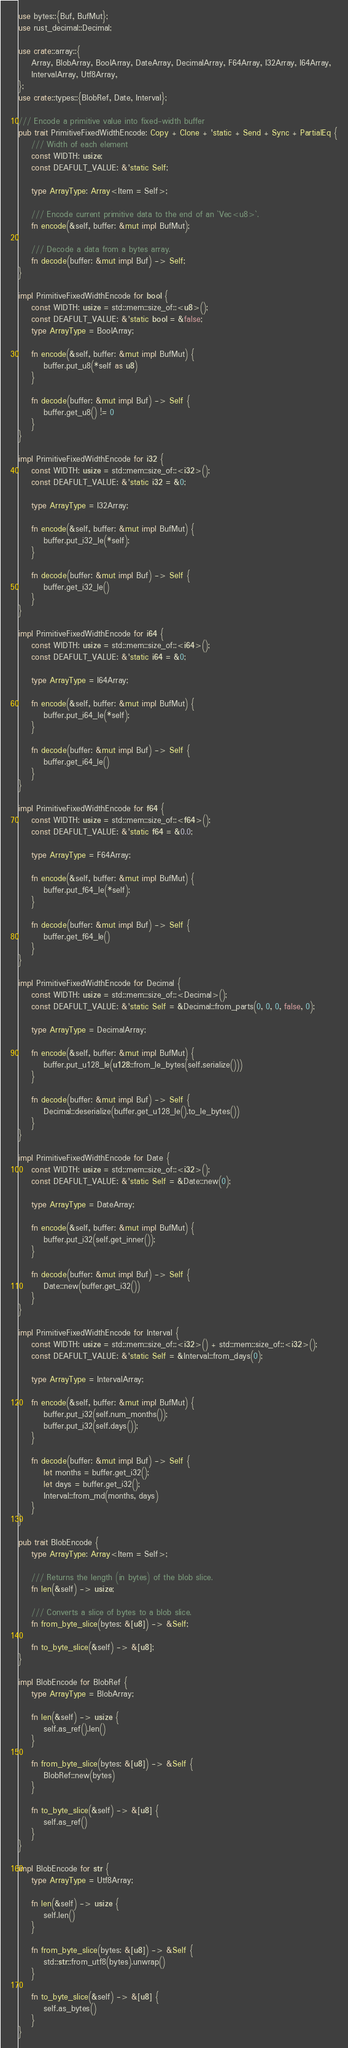<code> <loc_0><loc_0><loc_500><loc_500><_Rust_>
use bytes::{Buf, BufMut};
use rust_decimal::Decimal;

use crate::array::{
    Array, BlobArray, BoolArray, DateArray, DecimalArray, F64Array, I32Array, I64Array,
    IntervalArray, Utf8Array,
};
use crate::types::{BlobRef, Date, Interval};

/// Encode a primitive value into fixed-width buffer
pub trait PrimitiveFixedWidthEncode: Copy + Clone + 'static + Send + Sync + PartialEq {
    /// Width of each element
    const WIDTH: usize;
    const DEAFULT_VALUE: &'static Self;

    type ArrayType: Array<Item = Self>;

    /// Encode current primitive data to the end of an `Vec<u8>`.
    fn encode(&self, buffer: &mut impl BufMut);

    /// Decode a data from a bytes array.
    fn decode(buffer: &mut impl Buf) -> Self;
}

impl PrimitiveFixedWidthEncode for bool {
    const WIDTH: usize = std::mem::size_of::<u8>();
    const DEAFULT_VALUE: &'static bool = &false;
    type ArrayType = BoolArray;

    fn encode(&self, buffer: &mut impl BufMut) {
        buffer.put_u8(*self as u8)
    }

    fn decode(buffer: &mut impl Buf) -> Self {
        buffer.get_u8() != 0
    }
}

impl PrimitiveFixedWidthEncode for i32 {
    const WIDTH: usize = std::mem::size_of::<i32>();
    const DEAFULT_VALUE: &'static i32 = &0;

    type ArrayType = I32Array;

    fn encode(&self, buffer: &mut impl BufMut) {
        buffer.put_i32_le(*self);
    }

    fn decode(buffer: &mut impl Buf) -> Self {
        buffer.get_i32_le()
    }
}

impl PrimitiveFixedWidthEncode for i64 {
    const WIDTH: usize = std::mem::size_of::<i64>();
    const DEAFULT_VALUE: &'static i64 = &0;

    type ArrayType = I64Array;

    fn encode(&self, buffer: &mut impl BufMut) {
        buffer.put_i64_le(*self);
    }

    fn decode(buffer: &mut impl Buf) -> Self {
        buffer.get_i64_le()
    }
}

impl PrimitiveFixedWidthEncode for f64 {
    const WIDTH: usize = std::mem::size_of::<f64>();
    const DEAFULT_VALUE: &'static f64 = &0.0;

    type ArrayType = F64Array;

    fn encode(&self, buffer: &mut impl BufMut) {
        buffer.put_f64_le(*self);
    }

    fn decode(buffer: &mut impl Buf) -> Self {
        buffer.get_f64_le()
    }
}

impl PrimitiveFixedWidthEncode for Decimal {
    const WIDTH: usize = std::mem::size_of::<Decimal>();
    const DEAFULT_VALUE: &'static Self = &Decimal::from_parts(0, 0, 0, false, 0);

    type ArrayType = DecimalArray;

    fn encode(&self, buffer: &mut impl BufMut) {
        buffer.put_u128_le(u128::from_le_bytes(self.serialize()))
    }

    fn decode(buffer: &mut impl Buf) -> Self {
        Decimal::deserialize(buffer.get_u128_le().to_le_bytes())
    }
}

impl PrimitiveFixedWidthEncode for Date {
    const WIDTH: usize = std::mem::size_of::<i32>();
    const DEAFULT_VALUE: &'static Self = &Date::new(0);

    type ArrayType = DateArray;

    fn encode(&self, buffer: &mut impl BufMut) {
        buffer.put_i32(self.get_inner());
    }

    fn decode(buffer: &mut impl Buf) -> Self {
        Date::new(buffer.get_i32())
    }
}

impl PrimitiveFixedWidthEncode for Interval {
    const WIDTH: usize = std::mem::size_of::<i32>() + std::mem::size_of::<i32>();
    const DEAFULT_VALUE: &'static Self = &Interval::from_days(0);

    type ArrayType = IntervalArray;

    fn encode(&self, buffer: &mut impl BufMut) {
        buffer.put_i32(self.num_months());
        buffer.put_i32(self.days());
    }

    fn decode(buffer: &mut impl Buf) -> Self {
        let months = buffer.get_i32();
        let days = buffer.get_i32();
        Interval::from_md(months, days)
    }
}

pub trait BlobEncode {
    type ArrayType: Array<Item = Self>;

    /// Returns the length (in bytes) of the blob slice.
    fn len(&self) -> usize;

    /// Converts a slice of bytes to a blob slice.
    fn from_byte_slice(bytes: &[u8]) -> &Self;

    fn to_byte_slice(&self) -> &[u8];
}

impl BlobEncode for BlobRef {
    type ArrayType = BlobArray;

    fn len(&self) -> usize {
        self.as_ref().len()
    }

    fn from_byte_slice(bytes: &[u8]) -> &Self {
        BlobRef::new(bytes)
    }

    fn to_byte_slice(&self) -> &[u8] {
        self.as_ref()
    }
}

impl BlobEncode for str {
    type ArrayType = Utf8Array;

    fn len(&self) -> usize {
        self.len()
    }

    fn from_byte_slice(bytes: &[u8]) -> &Self {
        std::str::from_utf8(bytes).unwrap()
    }

    fn to_byte_slice(&self) -> &[u8] {
        self.as_bytes()
    }
}
</code> 